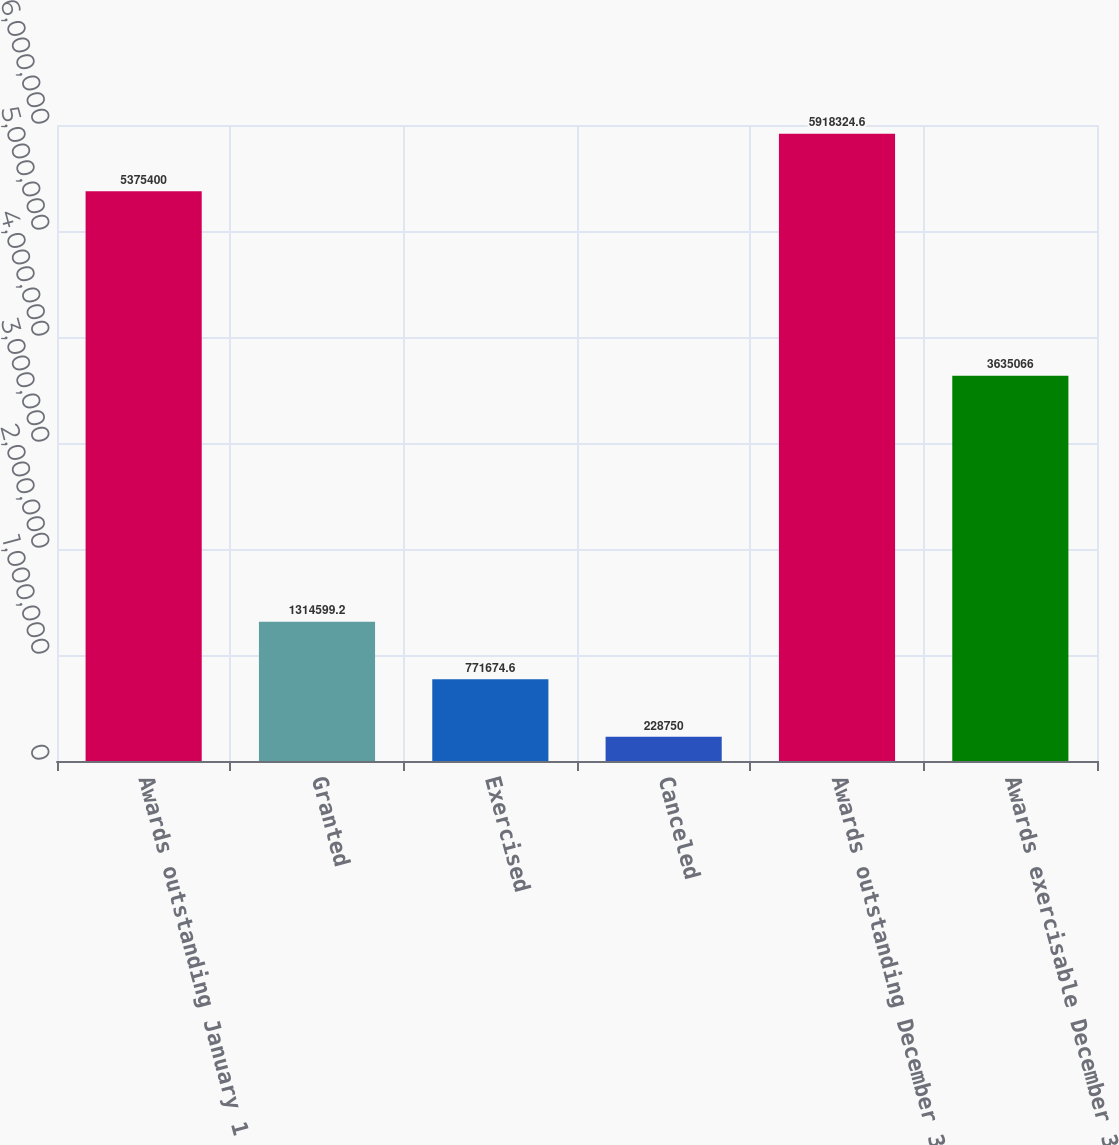Convert chart to OTSL. <chart><loc_0><loc_0><loc_500><loc_500><bar_chart><fcel>Awards outstanding January 1<fcel>Granted<fcel>Exercised<fcel>Canceled<fcel>Awards outstanding December 31<fcel>Awards exercisable December 31<nl><fcel>5.3754e+06<fcel>1.3146e+06<fcel>771675<fcel>228750<fcel>5.91832e+06<fcel>3.63507e+06<nl></chart> 